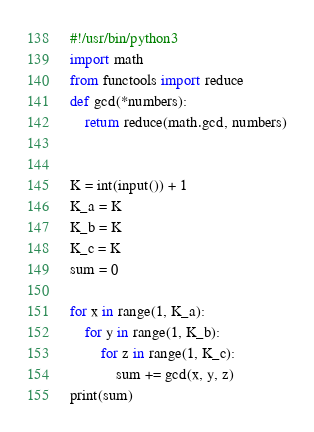Convert code to text. <code><loc_0><loc_0><loc_500><loc_500><_Python_>#!/usr/bin/python3
import math
from functools import reduce
def gcd(*numbers):
    return reduce(math.gcd, numbers)


K = int(input()) + 1
K_a = K
K_b = K
K_c = K
sum = 0

for x in range(1, K_a):
    for y in range(1, K_b):
        for z in range(1, K_c):
            sum += gcd(x, y, z)
print(sum)</code> 